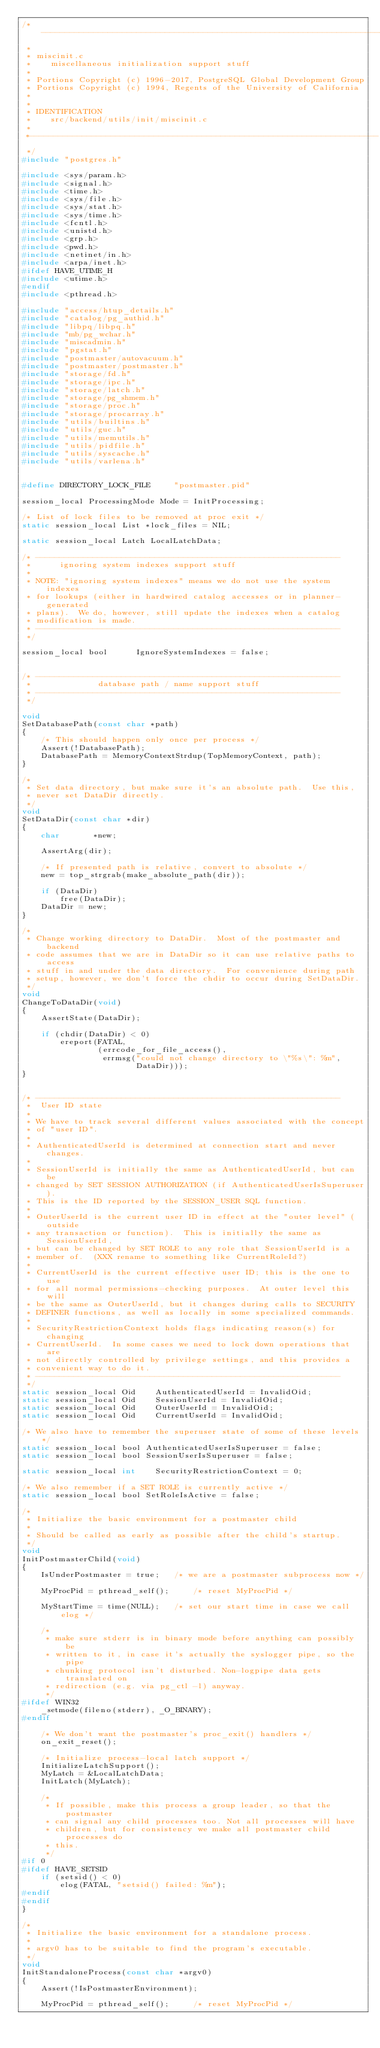Convert code to text. <code><loc_0><loc_0><loc_500><loc_500><_C_>/*-------------------------------------------------------------------------
 *
 * miscinit.c
 *	  miscellaneous initialization support stuff
 *
 * Portions Copyright (c) 1996-2017, PostgreSQL Global Development Group
 * Portions Copyright (c) 1994, Regents of the University of California
 *
 *
 * IDENTIFICATION
 *	  src/backend/utils/init/miscinit.c
 *
 *-------------------------------------------------------------------------
 */
#include "postgres.h"

#include <sys/param.h>
#include <signal.h>
#include <time.h>
#include <sys/file.h>
#include <sys/stat.h>
#include <sys/time.h>
#include <fcntl.h>
#include <unistd.h>
#include <grp.h>
#include <pwd.h>
#include <netinet/in.h>
#include <arpa/inet.h>
#ifdef HAVE_UTIME_H
#include <utime.h>
#endif
#include <pthread.h>

#include "access/htup_details.h"
#include "catalog/pg_authid.h"
#include "libpq/libpq.h"
#include "mb/pg_wchar.h"
#include "miscadmin.h"
#include "pgstat.h"
#include "postmaster/autovacuum.h"
#include "postmaster/postmaster.h"
#include "storage/fd.h"
#include "storage/ipc.h"
#include "storage/latch.h"
#include "storage/pg_shmem.h"
#include "storage/proc.h"
#include "storage/procarray.h"
#include "utils/builtins.h"
#include "utils/guc.h"
#include "utils/memutils.h"
#include "utils/pidfile.h"
#include "utils/syscache.h"
#include "utils/varlena.h"


#define DIRECTORY_LOCK_FILE		"postmaster.pid"

session_local ProcessingMode Mode = InitProcessing;

/* List of lock files to be removed at proc exit */
static session_local List *lock_files = NIL;

static session_local Latch LocalLatchData;

/* ----------------------------------------------------------------
 *		ignoring system indexes support stuff
 *
 * NOTE: "ignoring system indexes" means we do not use the system indexes
 * for lookups (either in hardwired catalog accesses or in planner-generated
 * plans).  We do, however, still update the indexes when a catalog
 * modification is made.
 * ----------------------------------------------------------------
 */

session_local bool		IgnoreSystemIndexes = false;


/* ----------------------------------------------------------------
 *				database path / name support stuff
 * ----------------------------------------------------------------
 */

void
SetDatabasePath(const char *path)
{
	/* This should happen only once per process */
	Assert(!DatabasePath);
	DatabasePath = MemoryContextStrdup(TopMemoryContext, path);
}

/*
 * Set data directory, but make sure it's an absolute path.  Use this,
 * never set DataDir directly.
 */
void
SetDataDir(const char *dir)
{
	char	   *new;

	AssertArg(dir);

	/* If presented path is relative, convert to absolute */
	new = top_strgrab(make_absolute_path(dir));

	if (DataDir)
		free(DataDir);
	DataDir = new;
}

/*
 * Change working directory to DataDir.  Most of the postmaster and backend
 * code assumes that we are in DataDir so it can use relative paths to access
 * stuff in and under the data directory.  For convenience during path
 * setup, however, we don't force the chdir to occur during SetDataDir.
 */
void
ChangeToDataDir(void)
{
	AssertState(DataDir);

	if (chdir(DataDir) < 0)
		ereport(FATAL,
				(errcode_for_file_access(),
				 errmsg("could not change directory to \"%s\": %m",
						DataDir)));
}


/* ----------------------------------------------------------------
 *	User ID state
 *
 * We have to track several different values associated with the concept
 * of "user ID".
 *
 * AuthenticatedUserId is determined at connection start and never changes.
 *
 * SessionUserId is initially the same as AuthenticatedUserId, but can be
 * changed by SET SESSION AUTHORIZATION (if AuthenticatedUserIsSuperuser).
 * This is the ID reported by the SESSION_USER SQL function.
 *
 * OuterUserId is the current user ID in effect at the "outer level" (outside
 * any transaction or function).  This is initially the same as SessionUserId,
 * but can be changed by SET ROLE to any role that SessionUserId is a
 * member of.  (XXX rename to something like CurrentRoleId?)
 *
 * CurrentUserId is the current effective user ID; this is the one to use
 * for all normal permissions-checking purposes.  At outer level this will
 * be the same as OuterUserId, but it changes during calls to SECURITY
 * DEFINER functions, as well as locally in some specialized commands.
 *
 * SecurityRestrictionContext holds flags indicating reason(s) for changing
 * CurrentUserId.  In some cases we need to lock down operations that are
 * not directly controlled by privilege settings, and this provides a
 * convenient way to do it.
 * ----------------------------------------------------------------
 */
static session_local Oid	AuthenticatedUserId = InvalidOid;
static session_local Oid	SessionUserId = InvalidOid;
static session_local Oid	OuterUserId = InvalidOid;
static session_local Oid	CurrentUserId = InvalidOid;

/* We also have to remember the superuser state of some of these levels */
static session_local bool AuthenticatedUserIsSuperuser = false;
static session_local bool SessionUserIsSuperuser = false;

static session_local int	SecurityRestrictionContext = 0;

/* We also remember if a SET ROLE is currently active */
static session_local bool SetRoleIsActive = false;

/*
 * Initialize the basic environment for a postmaster child
 *
 * Should be called as early as possible after the child's startup.
 */
void
InitPostmasterChild(void)
{
	IsUnderPostmaster = true;	/* we are a postmaster subprocess now */

	MyProcPid = pthread_self();		/* reset MyProcPid */

	MyStartTime = time(NULL);	/* set our start time in case we call elog */

	/*
	 * make sure stderr is in binary mode before anything can possibly be
	 * written to it, in case it's actually the syslogger pipe, so the pipe
	 * chunking protocol isn't disturbed. Non-logpipe data gets translated on
	 * redirection (e.g. via pg_ctl -l) anyway.
	 */
#ifdef WIN32
	_setmode(fileno(stderr), _O_BINARY);
#endif

	/* We don't want the postmaster's proc_exit() handlers */
	on_exit_reset();

	/* Initialize process-local latch support */
	InitializeLatchSupport();
	MyLatch = &LocalLatchData;
	InitLatch(MyLatch);

	/*
	 * If possible, make this process a group leader, so that the postmaster
	 * can signal any child processes too. Not all processes will have
	 * children, but for consistency we make all postmaster child processes do
	 * this.
	 */
#if 0
#ifdef HAVE_SETSID
	if (setsid() < 0)
		elog(FATAL, "setsid() failed: %m");
#endif
#endif
}

/*
 * Initialize the basic environment for a standalone process.
 *
 * argv0 has to be suitable to find the program's executable.
 */
void
InitStandaloneProcess(const char *argv0)
{
	Assert(!IsPostmasterEnvironment);

	MyProcPid = pthread_self();		/* reset MyProcPid */
</code> 